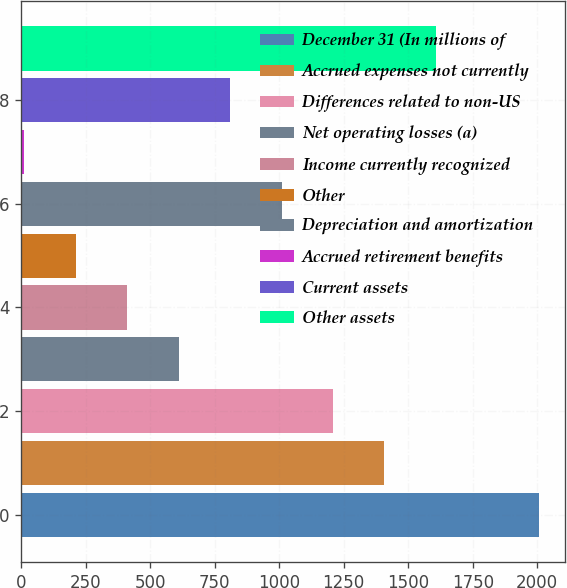Convert chart to OTSL. <chart><loc_0><loc_0><loc_500><loc_500><bar_chart><fcel>December 31 (In millions of<fcel>Accrued expenses not currently<fcel>Differences related to non-US<fcel>Net operating losses (a)<fcel>Income currently recognized<fcel>Other<fcel>Depreciation and amortization<fcel>Accrued retirement benefits<fcel>Current assets<fcel>Other assets<nl><fcel>2006<fcel>1407.8<fcel>1208.4<fcel>610.2<fcel>410.8<fcel>211.4<fcel>1009<fcel>12<fcel>809.6<fcel>1607.2<nl></chart> 